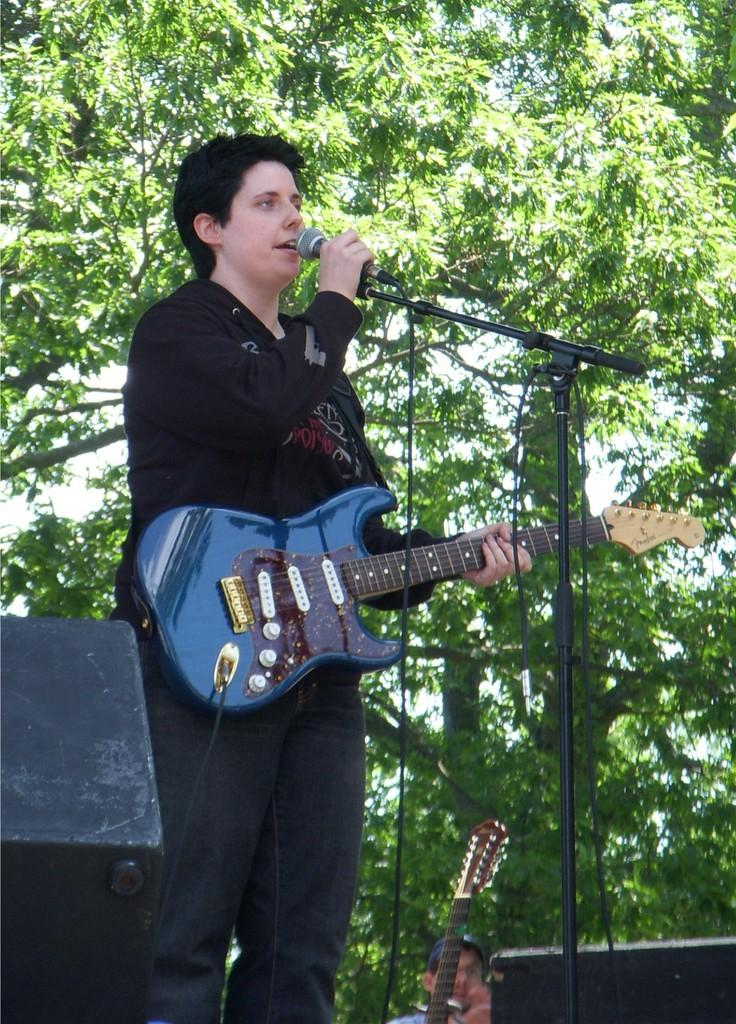What is the person in the image wearing? The person in the image is wearing a black jacket. What is the person holding in their hands? The person is holding a mic and a guitar. What can be seen in the background of the image? There are trees visible in the image. What type of sail can be seen on the person's teeth in the image? There is no sail present on the person's teeth in the image, as the person is holding a mic and a guitar, and there is no mention of teeth or a sail in the provided facts. 